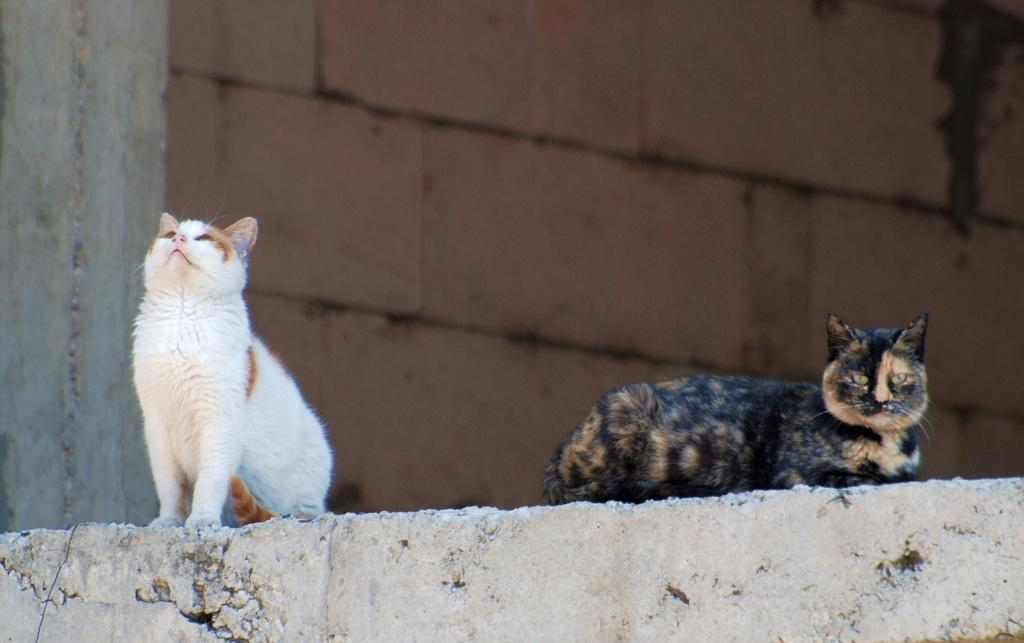How many cats are in the image? There are two cats in the image. Where are the cats located? The cats are on a wall. What colors can be seen on the cats? The cats have white, brown, and black coloring. What is the color of the background in the image? The background of the image is brown. What type of question is the cat wearing in the image? There is no question or clothing present in the image; it features two cats on a wall. What architectural feature can be seen in the image? There is no specific architectural feature mentioned in the provided facts, so it cannot be determined from the image. 